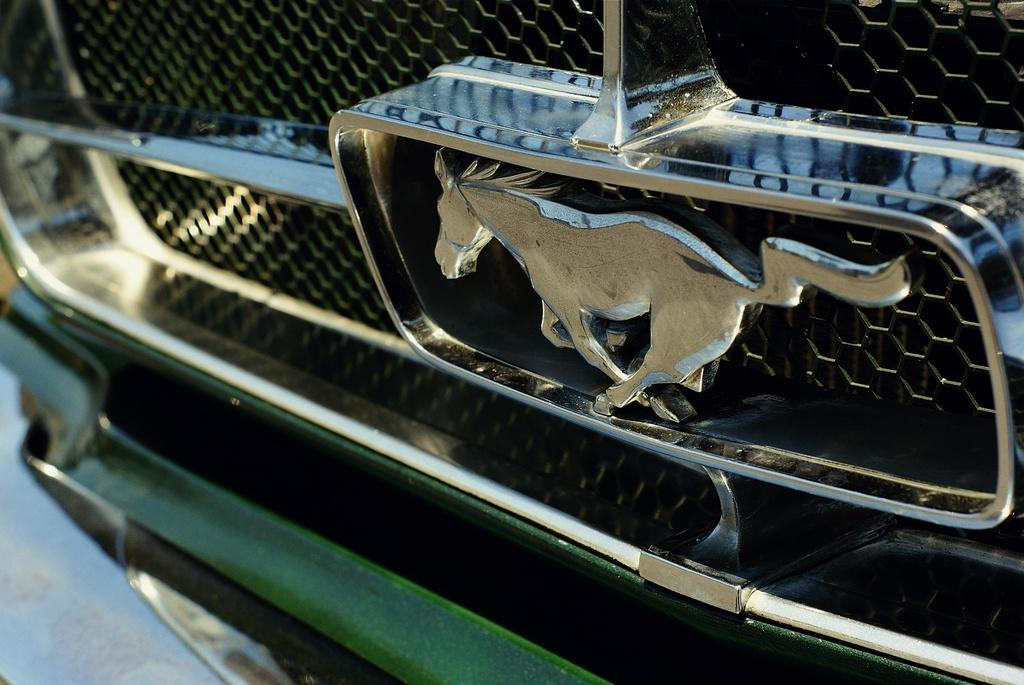What is the main subject of the image? There is a vehicle in the image. Can you describe the color of the vehicle? The vehicle is green in color. Is there any symbol or logo on the vehicle? Yes, the vehicle has a logo of a horse. What type of scissors can be seen in the image? There are no scissors present in the image. Is anyone wearing a mask in the image? There is no mention of a mask or any person wearing a mask in the image. --- Facts: 1. There is a person holding a book in the image. 2. The book has a red cover. 3. The person is sitting on a chair. 4. There is a table in front of the person. Absurd Topics: parrot, bicycle, ocean Conversation: What is the person in the image holding? The person is holding a book in the image. Can you describe the book's appearance? The book has a red cover. Where is the person sitting? The person is sitting on a chair. What is in front of the person? There is a table in front of the person. Reasoning: Let's think step by step in order to produce the conversation. We start by identifying the main subject of the image, which is the person holding a book. Then, we describe the appearance of the book, which has a red cover. Next, we mention the person's position, which is sitting on a chair. Finally, we describe the object in front of the person, which is a table. Each question is designed to elicit a specific detail about the image that is known from the provided facts. Absurd Question/Answer: Can you see a parrot sitting on the person's shoulder in the image? There is no mention of a parrot or any other animal in the image. Is the person riding a bicycle in the image? There is no mention of a bicycle in the image. 